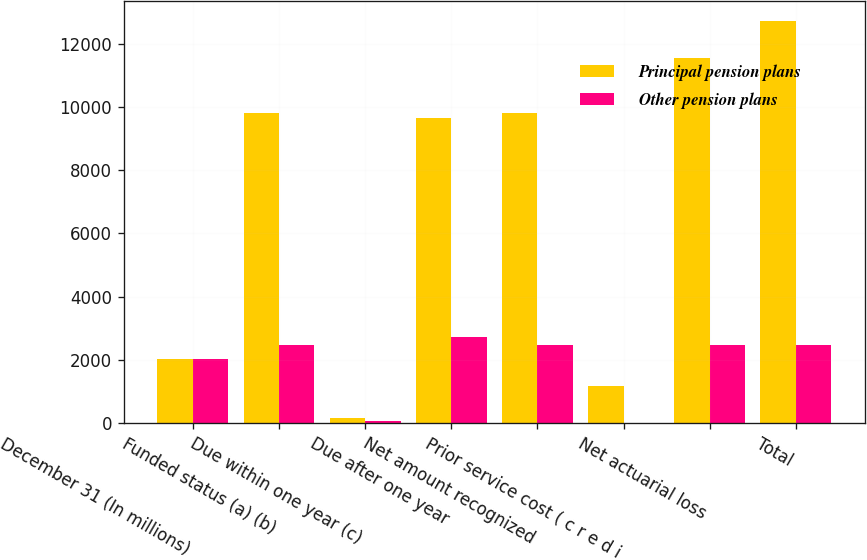<chart> <loc_0><loc_0><loc_500><loc_500><stacked_bar_chart><ecel><fcel>December 31 (In millions)<fcel>Funded status (a) (b)<fcel>Due within one year (c)<fcel>Due after one year<fcel>Net amount recognized<fcel>Prior service cost ( c r e d i<fcel>Net actuarial loss<fcel>Total<nl><fcel>Principal pension plans<fcel>2013<fcel>9816<fcel>170<fcel>9646<fcel>9816<fcel>1160<fcel>11555<fcel>12715<nl><fcel>Other pension plans<fcel>2013<fcel>2476<fcel>67<fcel>2734<fcel>2476<fcel>9<fcel>2459<fcel>2468<nl></chart> 